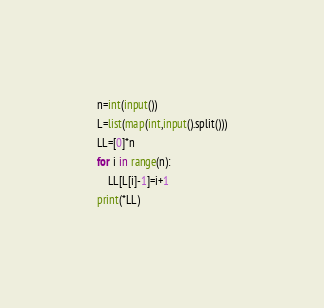Convert code to text. <code><loc_0><loc_0><loc_500><loc_500><_Python_>n=int(input())
L=list(map(int,input().split()))
LL=[0]*n
for i in range(n):
    LL[L[i]-1]=i+1
print(*LL)</code> 